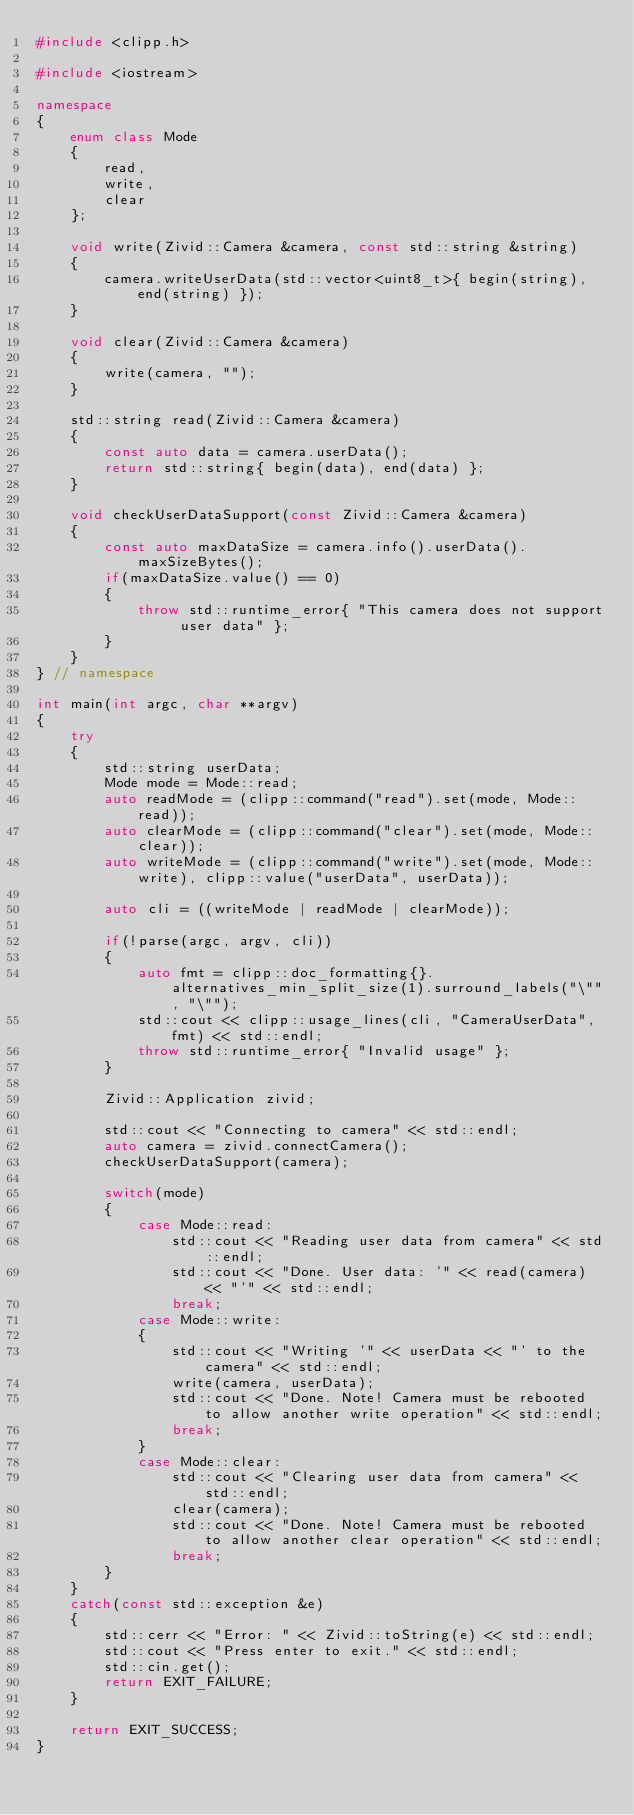Convert code to text. <code><loc_0><loc_0><loc_500><loc_500><_C++_>#include <clipp.h>

#include <iostream>

namespace
{
    enum class Mode
    {
        read,
        write,
        clear
    };

    void write(Zivid::Camera &camera, const std::string &string)
    {
        camera.writeUserData(std::vector<uint8_t>{ begin(string), end(string) });
    }

    void clear(Zivid::Camera &camera)
    {
        write(camera, "");
    }

    std::string read(Zivid::Camera &camera)
    {
        const auto data = camera.userData();
        return std::string{ begin(data), end(data) };
    }

    void checkUserDataSupport(const Zivid::Camera &camera)
    {
        const auto maxDataSize = camera.info().userData().maxSizeBytes();
        if(maxDataSize.value() == 0)
        {
            throw std::runtime_error{ "This camera does not support user data" };
        }
    }
} // namespace

int main(int argc, char **argv)
{
    try
    {
        std::string userData;
        Mode mode = Mode::read;
        auto readMode = (clipp::command("read").set(mode, Mode::read));
        auto clearMode = (clipp::command("clear").set(mode, Mode::clear));
        auto writeMode = (clipp::command("write").set(mode, Mode::write), clipp::value("userData", userData));

        auto cli = ((writeMode | readMode | clearMode));

        if(!parse(argc, argv, cli))
        {
            auto fmt = clipp::doc_formatting{}.alternatives_min_split_size(1).surround_labels("\"", "\"");
            std::cout << clipp::usage_lines(cli, "CameraUserData", fmt) << std::endl;
            throw std::runtime_error{ "Invalid usage" };
        }

        Zivid::Application zivid;

        std::cout << "Connecting to camera" << std::endl;
        auto camera = zivid.connectCamera();
        checkUserDataSupport(camera);

        switch(mode)
        {
            case Mode::read:
                std::cout << "Reading user data from camera" << std::endl;
                std::cout << "Done. User data: '" << read(camera) << "'" << std::endl;
                break;
            case Mode::write:
            {
                std::cout << "Writing '" << userData << "' to the camera" << std::endl;
                write(camera, userData);
                std::cout << "Done. Note! Camera must be rebooted to allow another write operation" << std::endl;
                break;
            }
            case Mode::clear:
                std::cout << "Clearing user data from camera" << std::endl;
                clear(camera);
                std::cout << "Done. Note! Camera must be rebooted to allow another clear operation" << std::endl;
                break;
        }
    }
    catch(const std::exception &e)
    {
        std::cerr << "Error: " << Zivid::toString(e) << std::endl;
        std::cout << "Press enter to exit." << std::endl;
        std::cin.get();
        return EXIT_FAILURE;
    }

    return EXIT_SUCCESS;
}
</code> 